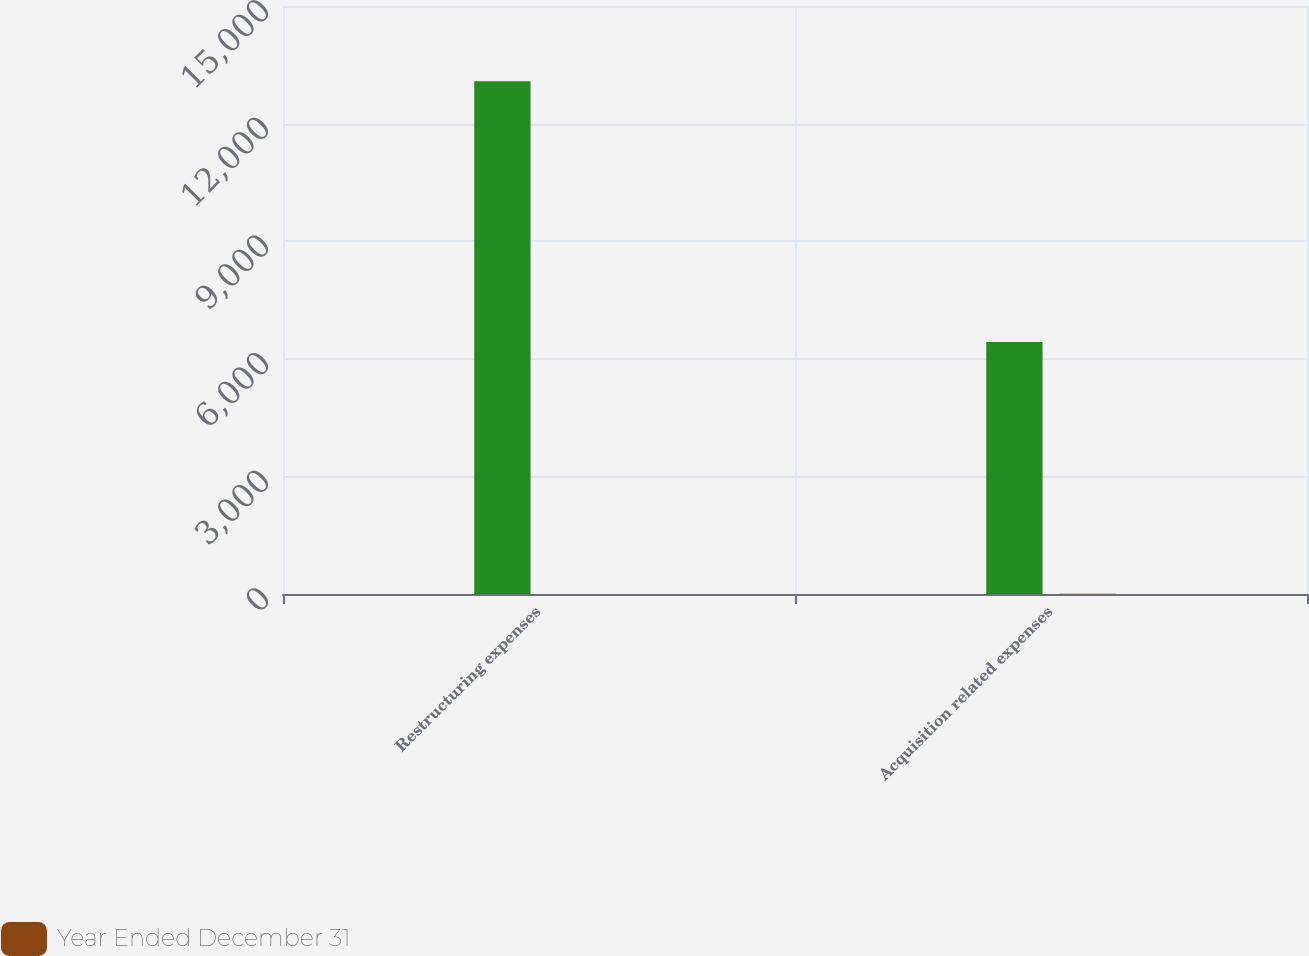<chart> <loc_0><loc_0><loc_500><loc_500><stacked_bar_chart><ecel><fcel>Restructuring expenses<fcel>Acquisition related expenses<nl><fcel>nan<fcel>13083<fcel>6428<nl><fcel>Year Ended December 31<fcel>2<fcel>4<nl></chart> 